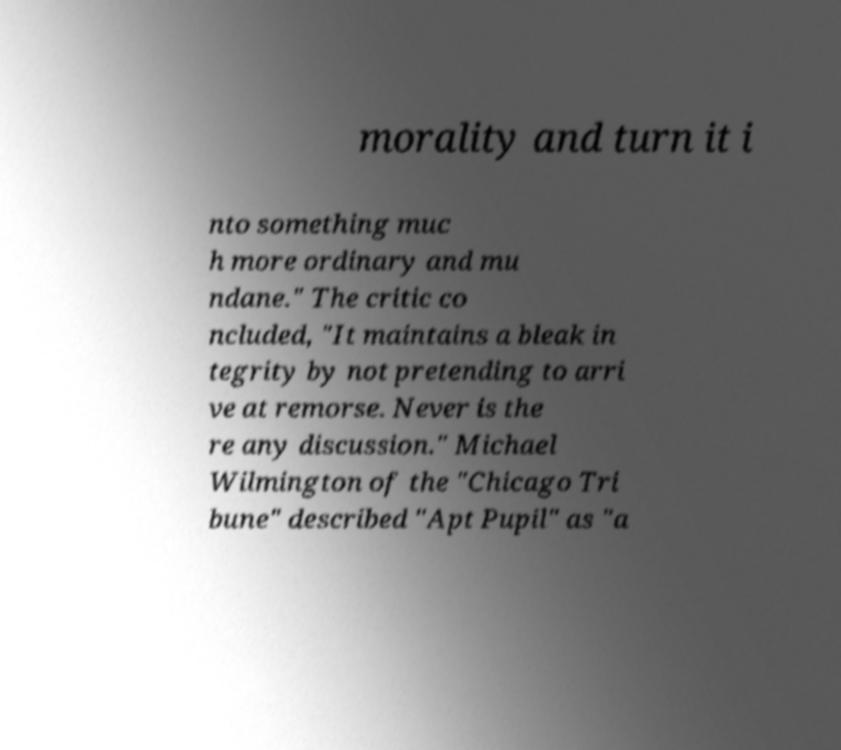Could you assist in decoding the text presented in this image and type it out clearly? morality and turn it i nto something muc h more ordinary and mu ndane." The critic co ncluded, "It maintains a bleak in tegrity by not pretending to arri ve at remorse. Never is the re any discussion." Michael Wilmington of the "Chicago Tri bune" described "Apt Pupil" as "a 